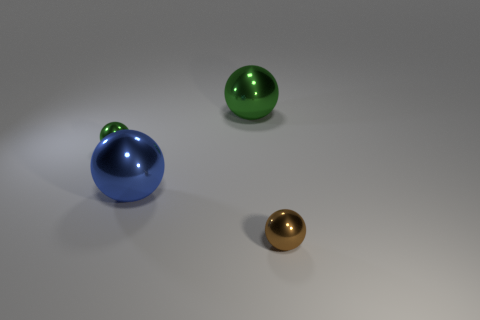Are there more green balls that are on the left side of the large green shiny object than small green shiny things?
Offer a terse response. No. How many large things are either shiny objects or brown shiny objects?
Ensure brevity in your answer.  2. How many large green things have the same shape as the brown object?
Offer a terse response. 1. What material is the small sphere left of the small thing right of the blue metallic object?
Offer a very short reply. Metal. How big is the metallic sphere that is on the right side of the large green sphere?
Give a very brief answer. Small. How many green objects are balls or tiny shiny objects?
Provide a succinct answer. 2. Is there any other thing that has the same material as the big green sphere?
Offer a very short reply. Yes. There is a brown object that is the same shape as the small green shiny object; what material is it?
Your response must be concise. Metal. Are there an equal number of tiny brown spheres that are left of the large blue metallic thing and big blue blocks?
Provide a short and direct response. Yes. There is a ball that is both to the right of the tiny green metal ball and behind the large blue metallic thing; how big is it?
Offer a terse response. Large. 